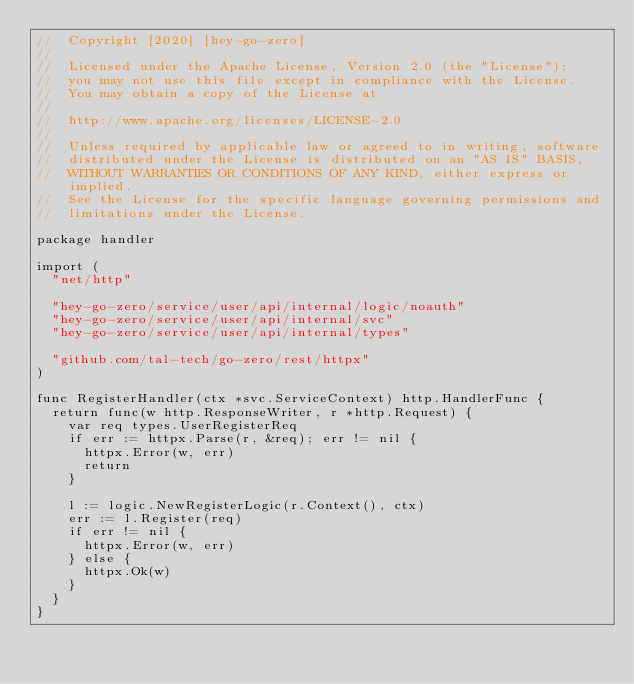Convert code to text. <code><loc_0><loc_0><loc_500><loc_500><_Go_>//  Copyright [2020] [hey-go-zero]
//
//  Licensed under the Apache License, Version 2.0 (the "License");
//  you may not use this file except in compliance with the License.
//  You may obtain a copy of the License at
//
//  http://www.apache.org/licenses/LICENSE-2.0
//
//  Unless required by applicable law or agreed to in writing, software
//  distributed under the License is distributed on an "AS IS" BASIS,
//  WITHOUT WARRANTIES OR CONDITIONS OF ANY KIND, either express or implied.
//  See the License for the specific language governing permissions and
//  limitations under the License.

package handler

import (
	"net/http"

	"hey-go-zero/service/user/api/internal/logic/noauth"
	"hey-go-zero/service/user/api/internal/svc"
	"hey-go-zero/service/user/api/internal/types"

	"github.com/tal-tech/go-zero/rest/httpx"
)

func RegisterHandler(ctx *svc.ServiceContext) http.HandlerFunc {
	return func(w http.ResponseWriter, r *http.Request) {
		var req types.UserRegisterReq
		if err := httpx.Parse(r, &req); err != nil {
			httpx.Error(w, err)
			return
		}

		l := logic.NewRegisterLogic(r.Context(), ctx)
		err := l.Register(req)
		if err != nil {
			httpx.Error(w, err)
		} else {
			httpx.Ok(w)
		}
	}
}
</code> 